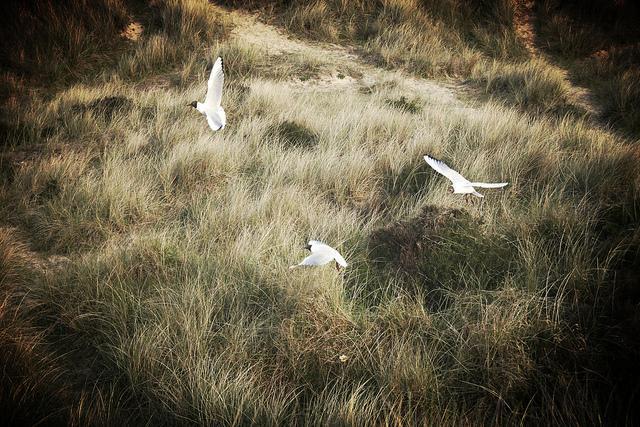How many windows on this bus face toward the traffic behind it?
Give a very brief answer. 0. 